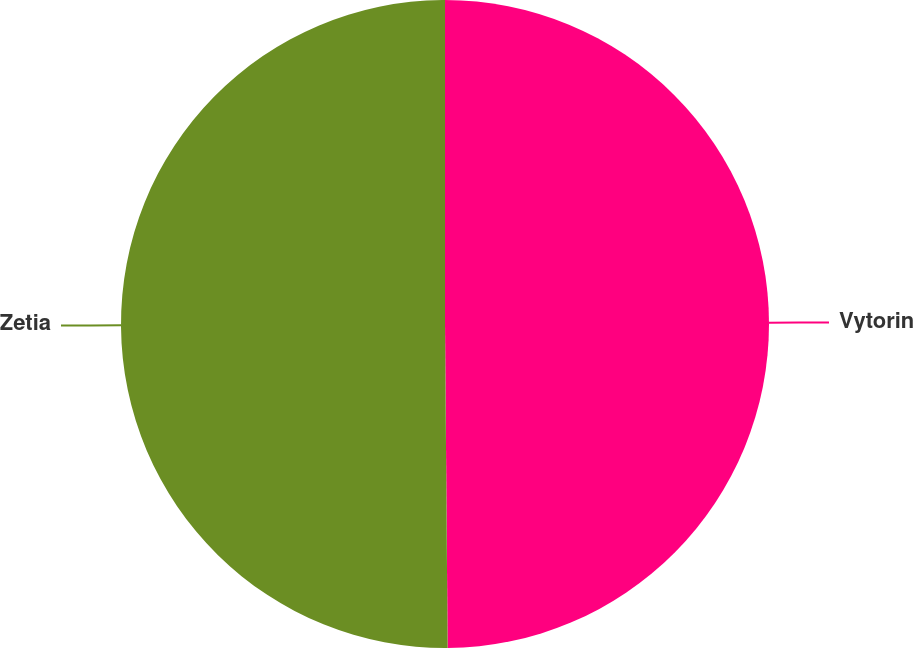Convert chart to OTSL. <chart><loc_0><loc_0><loc_500><loc_500><pie_chart><fcel>Vytorin<fcel>Zetia<nl><fcel>49.87%<fcel>50.13%<nl></chart> 